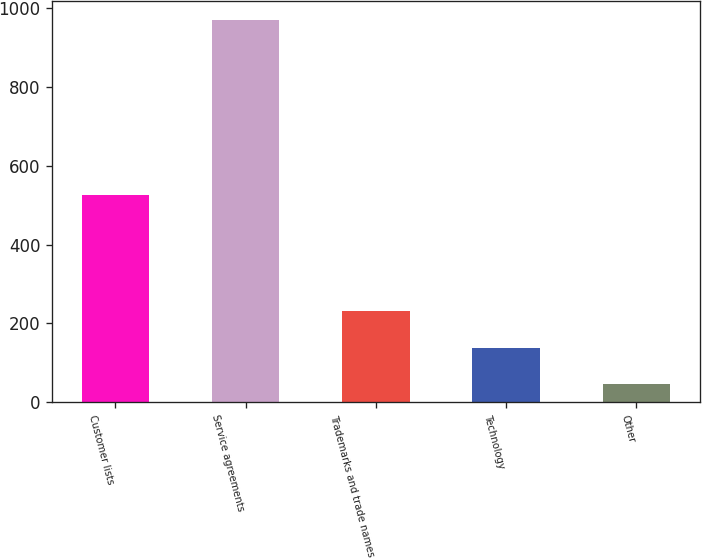<chart> <loc_0><loc_0><loc_500><loc_500><bar_chart><fcel>Customer lists<fcel>Service agreements<fcel>Trademarks and trade names<fcel>Technology<fcel>Other<nl><fcel>527<fcel>970<fcel>230<fcel>137.5<fcel>45<nl></chart> 